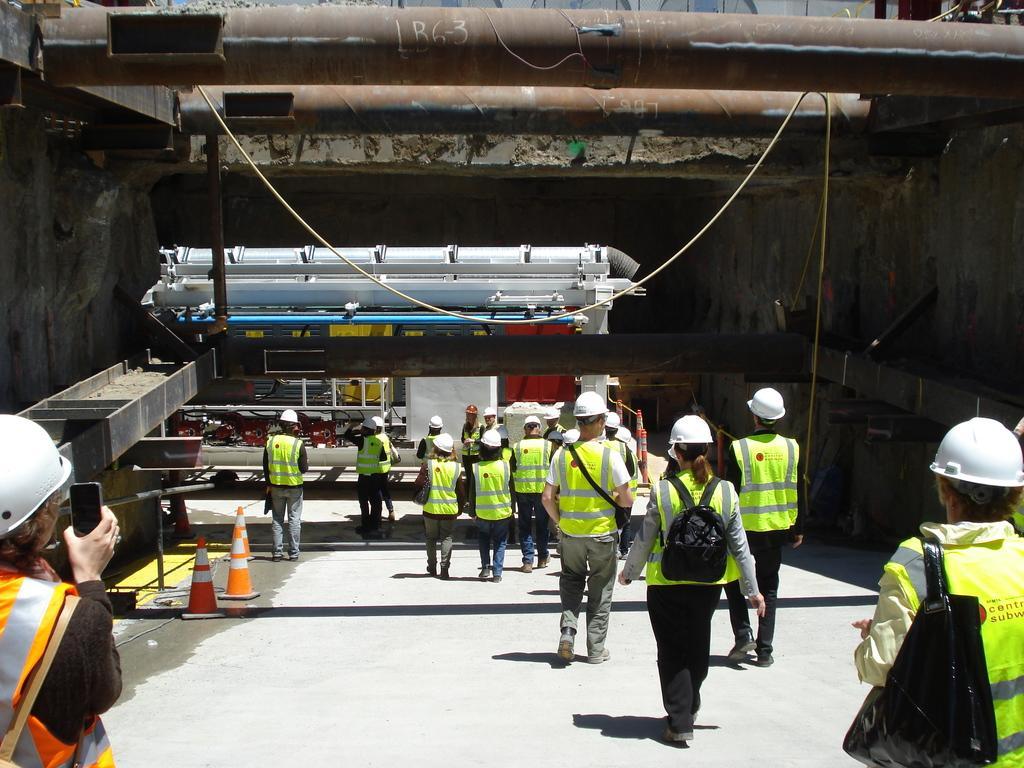How would you summarize this image in a sentence or two? In this image I can see the group of people with the aprons and the white color hats. I can see few people wearing the bags. To the left I can see some traffic cones. In the back I can see some metal rods. I can also see one person holding the mobile. 